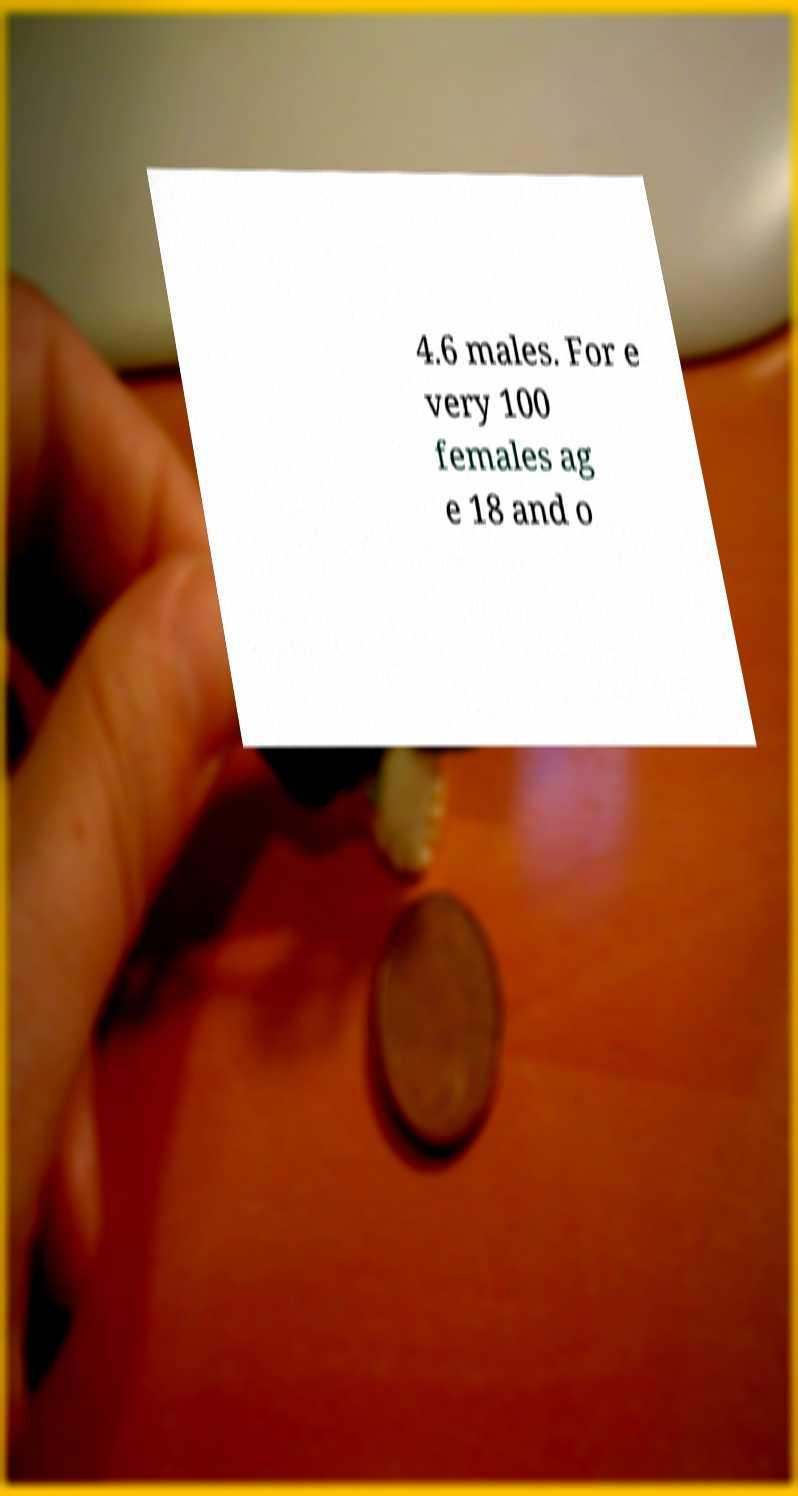Can you accurately transcribe the text from the provided image for me? 4.6 males. For e very 100 females ag e 18 and o 